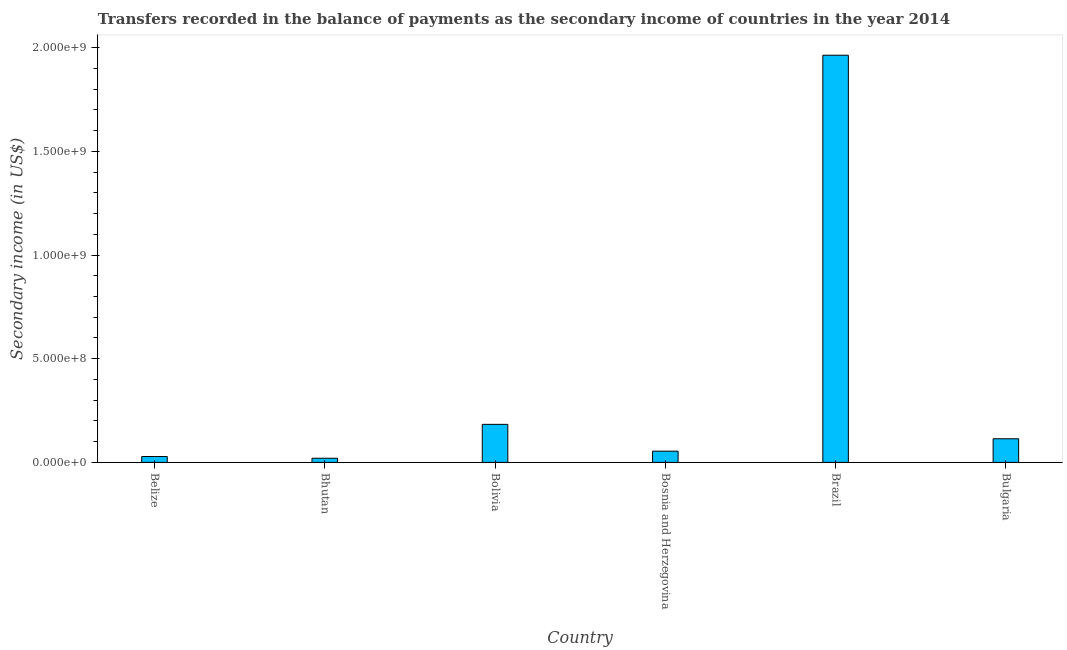Does the graph contain grids?
Your response must be concise. No. What is the title of the graph?
Provide a succinct answer. Transfers recorded in the balance of payments as the secondary income of countries in the year 2014. What is the label or title of the X-axis?
Make the answer very short. Country. What is the label or title of the Y-axis?
Offer a very short reply. Secondary income (in US$). What is the amount of secondary income in Brazil?
Your answer should be compact. 1.96e+09. Across all countries, what is the maximum amount of secondary income?
Give a very brief answer. 1.96e+09. Across all countries, what is the minimum amount of secondary income?
Keep it short and to the point. 2.00e+07. In which country was the amount of secondary income maximum?
Give a very brief answer. Brazil. In which country was the amount of secondary income minimum?
Ensure brevity in your answer.  Bhutan. What is the sum of the amount of secondary income?
Keep it short and to the point. 2.36e+09. What is the difference between the amount of secondary income in Belize and Bhutan?
Your response must be concise. 8.28e+06. What is the average amount of secondary income per country?
Provide a short and direct response. 3.94e+08. What is the median amount of secondary income?
Your response must be concise. 8.41e+07. In how many countries, is the amount of secondary income greater than 1000000000 US$?
Your answer should be very brief. 1. What is the ratio of the amount of secondary income in Bhutan to that in Bulgaria?
Make the answer very short. 0.18. Is the difference between the amount of secondary income in Bosnia and Herzegovina and Brazil greater than the difference between any two countries?
Your response must be concise. No. What is the difference between the highest and the second highest amount of secondary income?
Your answer should be compact. 1.78e+09. Is the sum of the amount of secondary income in Brazil and Bulgaria greater than the maximum amount of secondary income across all countries?
Provide a short and direct response. Yes. What is the difference between the highest and the lowest amount of secondary income?
Offer a terse response. 1.94e+09. In how many countries, is the amount of secondary income greater than the average amount of secondary income taken over all countries?
Your answer should be very brief. 1. How many bars are there?
Your response must be concise. 6. Are all the bars in the graph horizontal?
Give a very brief answer. No. How many countries are there in the graph?
Offer a terse response. 6. What is the Secondary income (in US$) of Belize?
Offer a very short reply. 2.83e+07. What is the Secondary income (in US$) of Bhutan?
Your response must be concise. 2.00e+07. What is the Secondary income (in US$) in Bolivia?
Your answer should be compact. 1.83e+08. What is the Secondary income (in US$) of Bosnia and Herzegovina?
Ensure brevity in your answer.  5.42e+07. What is the Secondary income (in US$) in Brazil?
Give a very brief answer. 1.96e+09. What is the Secondary income (in US$) in Bulgaria?
Offer a terse response. 1.14e+08. What is the difference between the Secondary income (in US$) in Belize and Bhutan?
Offer a terse response. 8.28e+06. What is the difference between the Secondary income (in US$) in Belize and Bolivia?
Provide a succinct answer. -1.55e+08. What is the difference between the Secondary income (in US$) in Belize and Bosnia and Herzegovina?
Keep it short and to the point. -2.59e+07. What is the difference between the Secondary income (in US$) in Belize and Brazil?
Your response must be concise. -1.94e+09. What is the difference between the Secondary income (in US$) in Belize and Bulgaria?
Offer a terse response. -8.57e+07. What is the difference between the Secondary income (in US$) in Bhutan and Bolivia?
Provide a succinct answer. -1.63e+08. What is the difference between the Secondary income (in US$) in Bhutan and Bosnia and Herzegovina?
Make the answer very short. -3.41e+07. What is the difference between the Secondary income (in US$) in Bhutan and Brazil?
Your answer should be very brief. -1.94e+09. What is the difference between the Secondary income (in US$) in Bhutan and Bulgaria?
Give a very brief answer. -9.40e+07. What is the difference between the Secondary income (in US$) in Bolivia and Bosnia and Herzegovina?
Provide a succinct answer. 1.29e+08. What is the difference between the Secondary income (in US$) in Bolivia and Brazil?
Your answer should be compact. -1.78e+09. What is the difference between the Secondary income (in US$) in Bolivia and Bulgaria?
Keep it short and to the point. 6.95e+07. What is the difference between the Secondary income (in US$) in Bosnia and Herzegovina and Brazil?
Offer a terse response. -1.91e+09. What is the difference between the Secondary income (in US$) in Bosnia and Herzegovina and Bulgaria?
Provide a succinct answer. -5.98e+07. What is the difference between the Secondary income (in US$) in Brazil and Bulgaria?
Give a very brief answer. 1.85e+09. What is the ratio of the Secondary income (in US$) in Belize to that in Bhutan?
Your answer should be very brief. 1.41. What is the ratio of the Secondary income (in US$) in Belize to that in Bolivia?
Provide a short and direct response. 0.15. What is the ratio of the Secondary income (in US$) in Belize to that in Bosnia and Herzegovina?
Offer a terse response. 0.52. What is the ratio of the Secondary income (in US$) in Belize to that in Brazil?
Your answer should be very brief. 0.01. What is the ratio of the Secondary income (in US$) in Belize to that in Bulgaria?
Offer a terse response. 0.25. What is the ratio of the Secondary income (in US$) in Bhutan to that in Bolivia?
Provide a succinct answer. 0.11. What is the ratio of the Secondary income (in US$) in Bhutan to that in Bosnia and Herzegovina?
Give a very brief answer. 0.37. What is the ratio of the Secondary income (in US$) in Bhutan to that in Brazil?
Provide a succinct answer. 0.01. What is the ratio of the Secondary income (in US$) in Bhutan to that in Bulgaria?
Offer a terse response. 0.18. What is the ratio of the Secondary income (in US$) in Bolivia to that in Bosnia and Herzegovina?
Ensure brevity in your answer.  3.39. What is the ratio of the Secondary income (in US$) in Bolivia to that in Brazil?
Your response must be concise. 0.09. What is the ratio of the Secondary income (in US$) in Bolivia to that in Bulgaria?
Make the answer very short. 1.61. What is the ratio of the Secondary income (in US$) in Bosnia and Herzegovina to that in Brazil?
Offer a very short reply. 0.03. What is the ratio of the Secondary income (in US$) in Bosnia and Herzegovina to that in Bulgaria?
Offer a very short reply. 0.47. What is the ratio of the Secondary income (in US$) in Brazil to that in Bulgaria?
Provide a short and direct response. 17.23. 